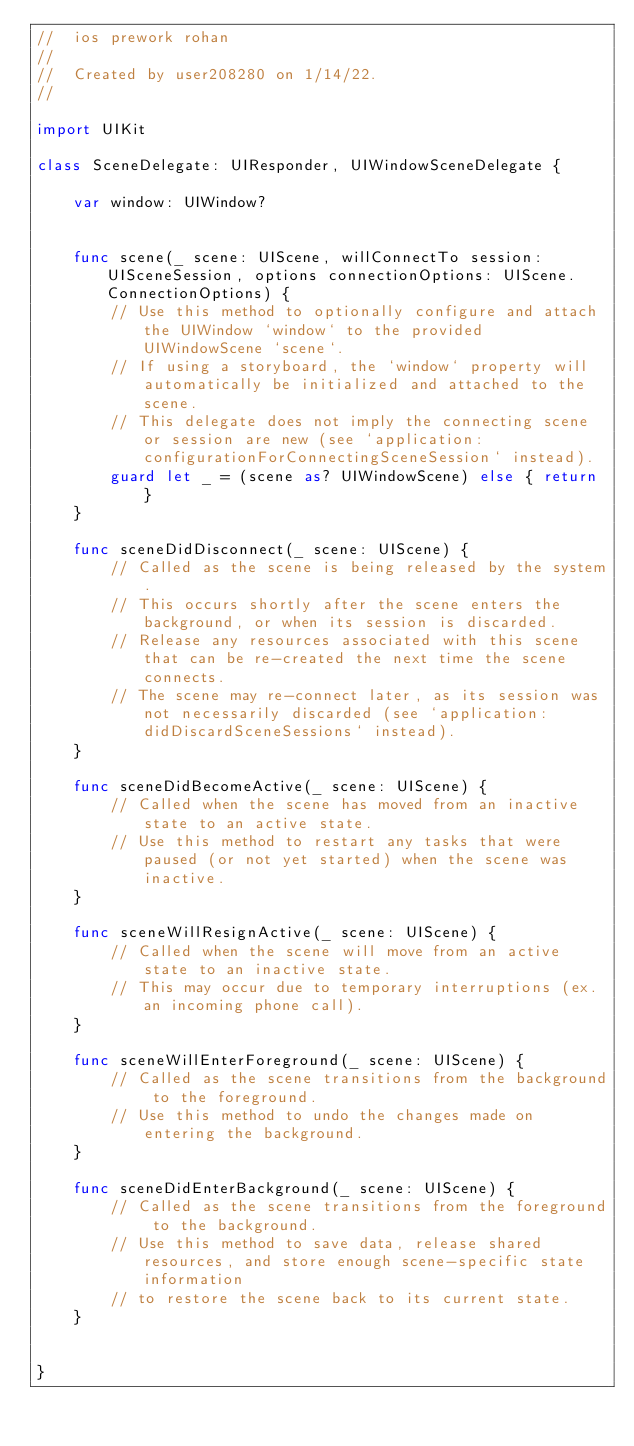<code> <loc_0><loc_0><loc_500><loc_500><_Swift_>//  ios prework rohan
//
//  Created by user208280 on 1/14/22.
//

import UIKit

class SceneDelegate: UIResponder, UIWindowSceneDelegate {

    var window: UIWindow?


    func scene(_ scene: UIScene, willConnectTo session: UISceneSession, options connectionOptions: UIScene.ConnectionOptions) {
        // Use this method to optionally configure and attach the UIWindow `window` to the provided UIWindowScene `scene`.
        // If using a storyboard, the `window` property will automatically be initialized and attached to the scene.
        // This delegate does not imply the connecting scene or session are new (see `application:configurationForConnectingSceneSession` instead).
        guard let _ = (scene as? UIWindowScene) else { return }
    }

    func sceneDidDisconnect(_ scene: UIScene) {
        // Called as the scene is being released by the system.
        // This occurs shortly after the scene enters the background, or when its session is discarded.
        // Release any resources associated with this scene that can be re-created the next time the scene connects.
        // The scene may re-connect later, as its session was not necessarily discarded (see `application:didDiscardSceneSessions` instead).
    }

    func sceneDidBecomeActive(_ scene: UIScene) {
        // Called when the scene has moved from an inactive state to an active state.
        // Use this method to restart any tasks that were paused (or not yet started) when the scene was inactive.
    }

    func sceneWillResignActive(_ scene: UIScene) {
        // Called when the scene will move from an active state to an inactive state.
        // This may occur due to temporary interruptions (ex. an incoming phone call).
    }

    func sceneWillEnterForeground(_ scene: UIScene) {
        // Called as the scene transitions from the background to the foreground.
        // Use this method to undo the changes made on entering the background.
    }

    func sceneDidEnterBackground(_ scene: UIScene) {
        // Called as the scene transitions from the foreground to the background.
        // Use this method to save data, release shared resources, and store enough scene-specific state information
        // to restore the scene back to its current state.
    }


}

</code> 